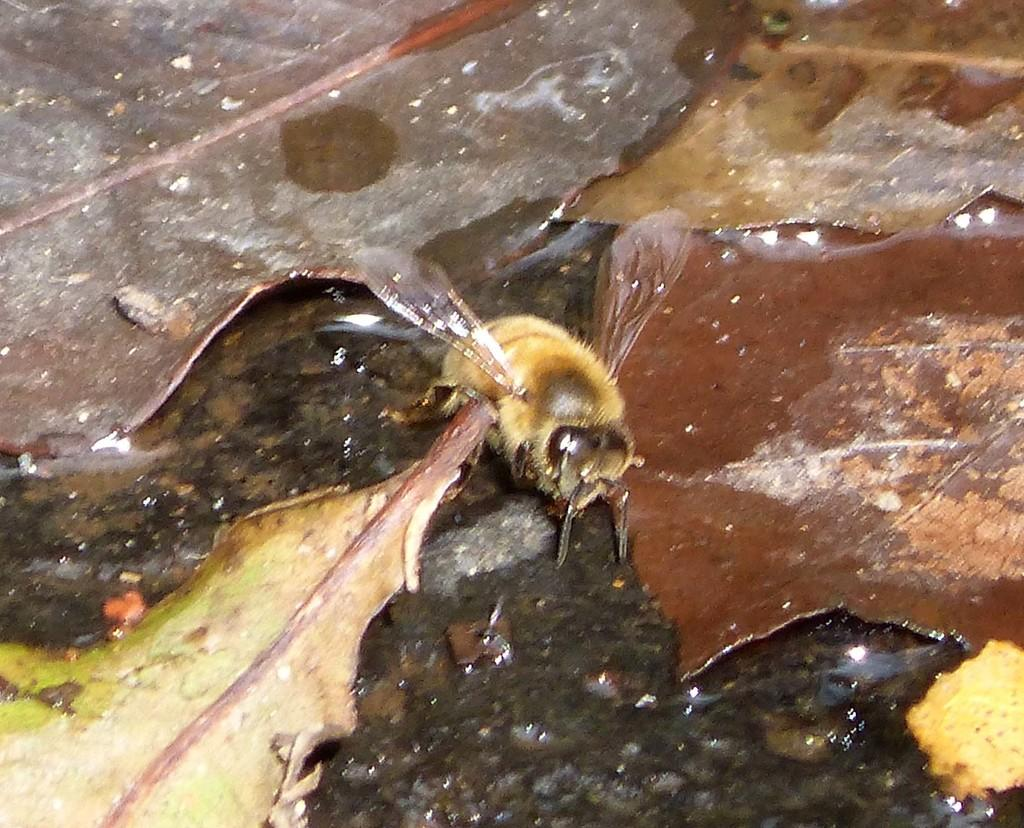What is present in the image? There is a fly in the image. What is the fly located on? The fly is on shredded leaves. What type of root can be seen growing from the fly in the image? There is no root growing from the fly in the image, as it is a fly and not a plant. 